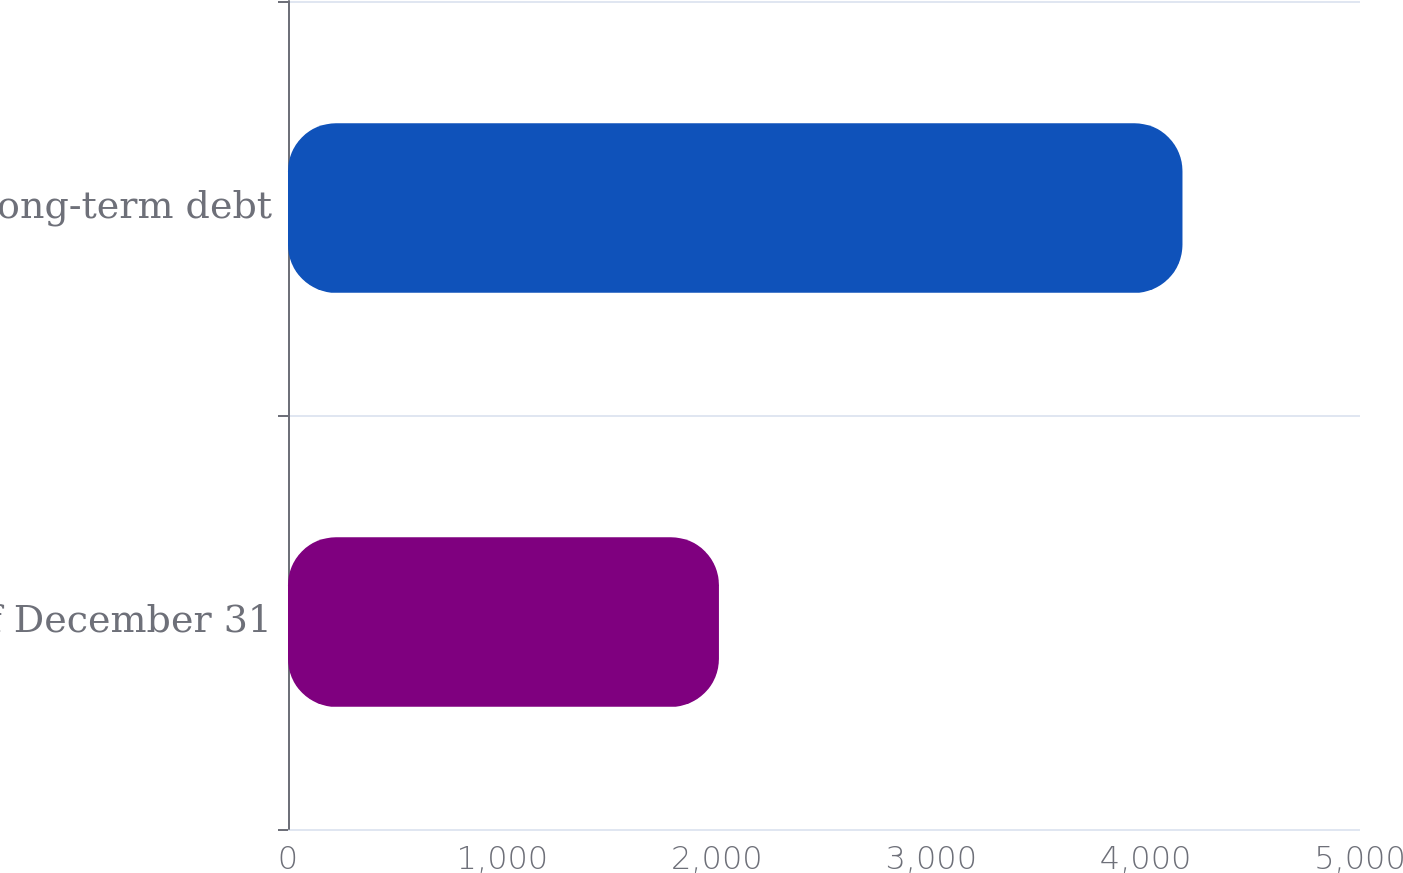Convert chart. <chart><loc_0><loc_0><loc_500><loc_500><bar_chart><fcel>As of December 31<fcel>Long-term debt<nl><fcel>2010<fcel>4172<nl></chart> 